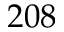Convert formula to latex. <formula><loc_0><loc_0><loc_500><loc_500>2 0 8</formula> 